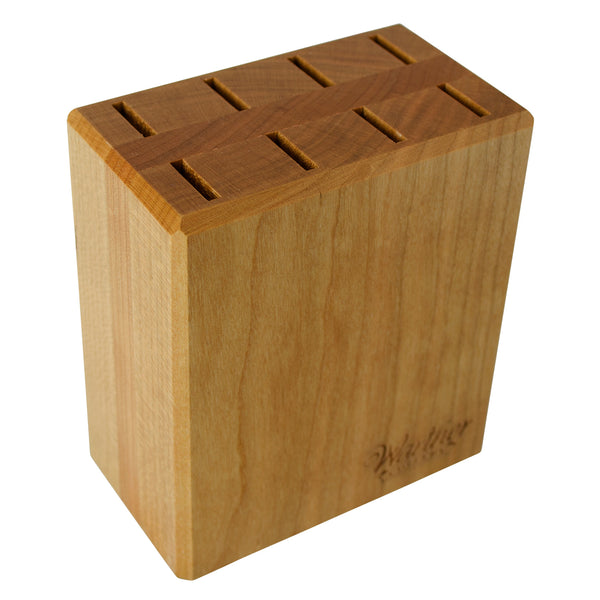Given the structure and design of the knife holder, what could be inferred about the types and sizes of knives it is intended to hold? The knife holder is designed to accommodate a range of knife sizes and types, indicative of its varied slot widths. This suggests it can house everything from narrow paring knives to wider chef's knives. The substantial uniformity and number of slots imply it's tailored for a comprehensive set which likely includes specialized knives such as a serrated bread knife, a sturdy carving knife, and versatile utility knives. The craftsmanship, evident in the carefully aligned slots and smooth wooden finish, also suggests attention to safety and ease of access, ensuring that knives can be stored and retrieved safely and efficiently. 